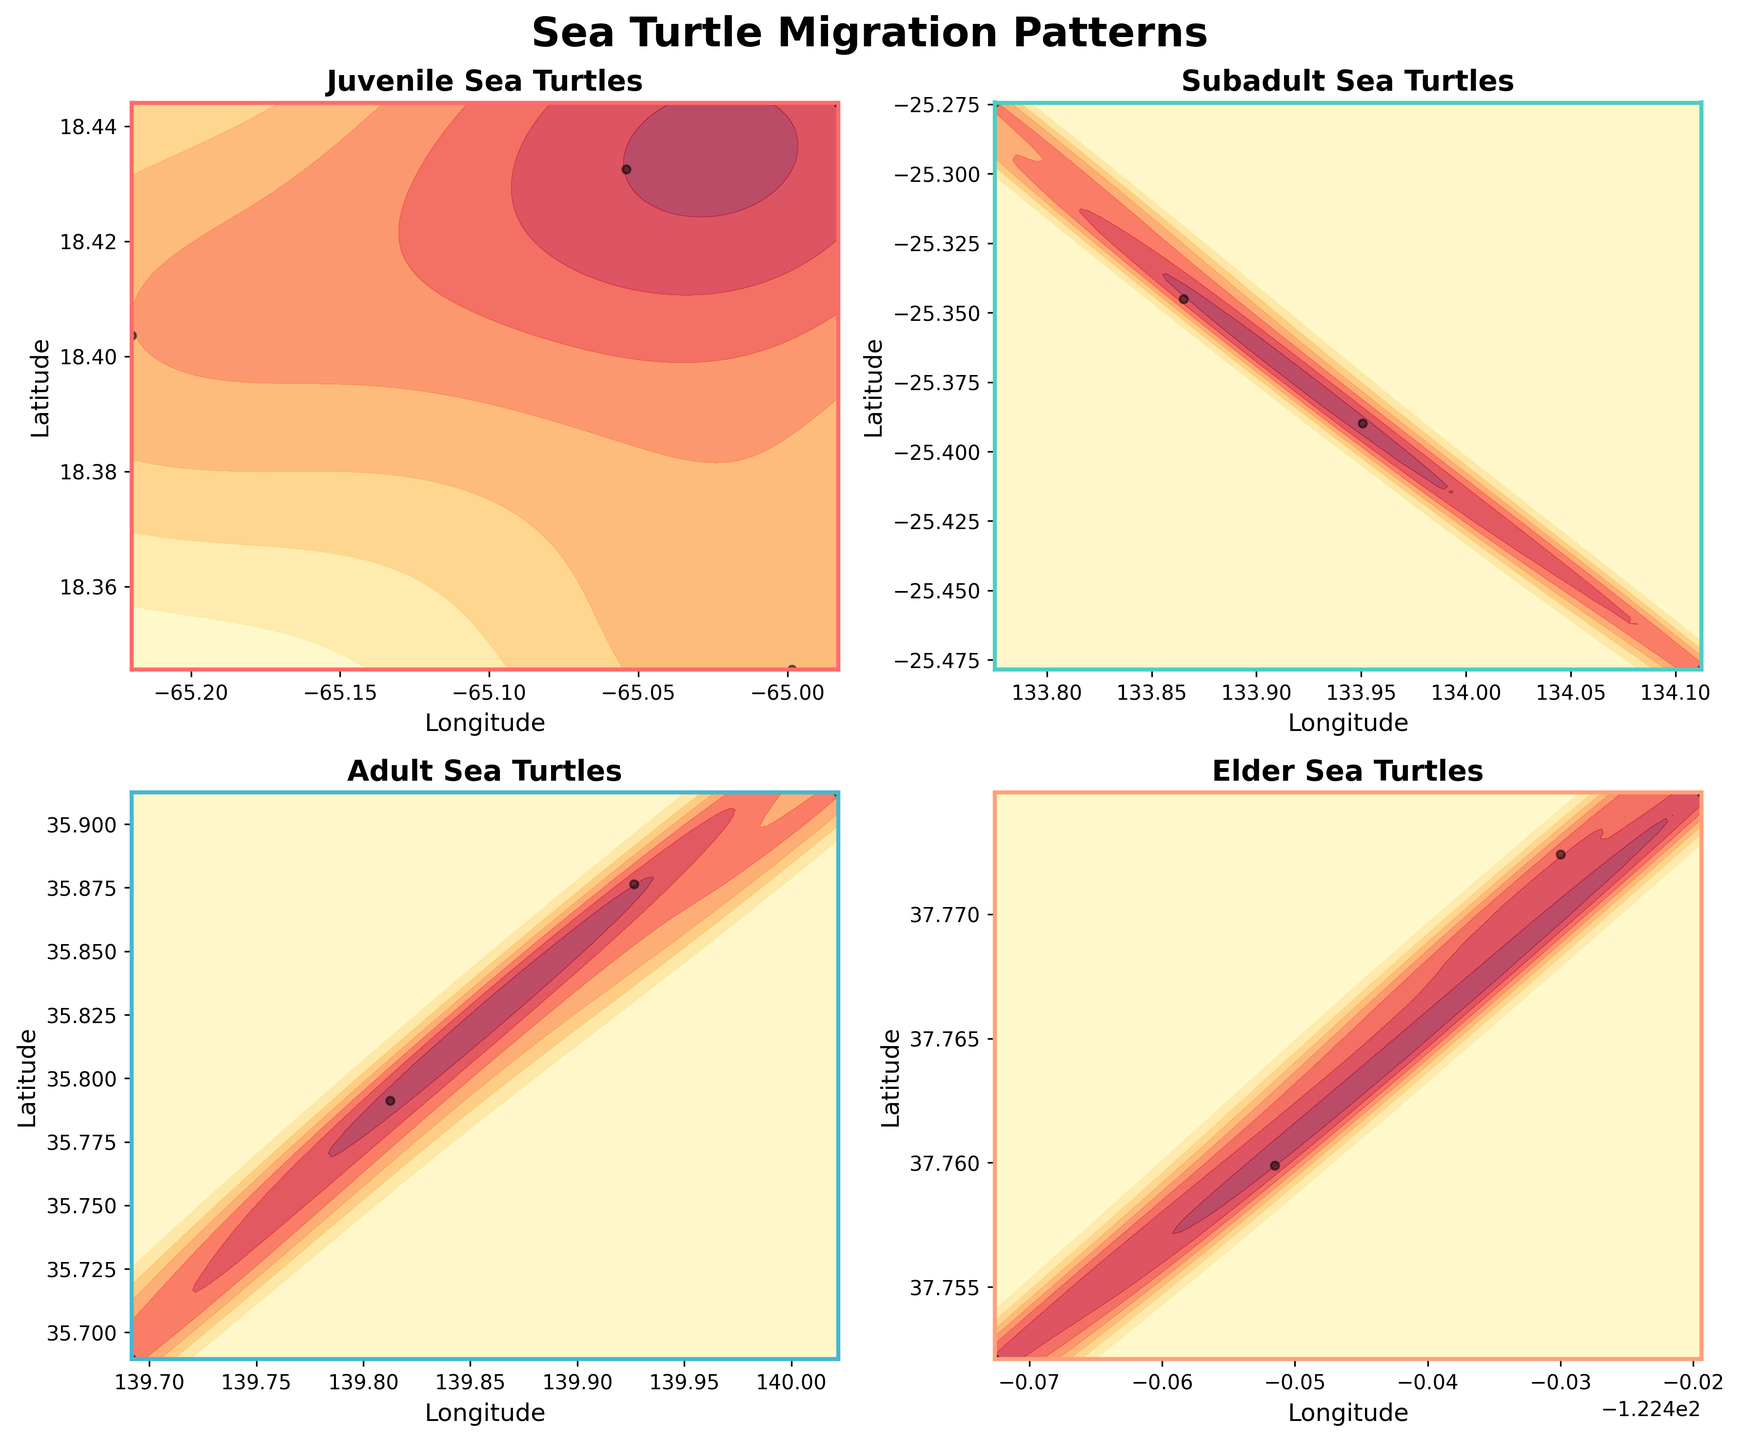Which age group is represented by the plot in the top-left subplot? The title for each subplot identifies the age group. The top-left subplot is labeled ‘Juvenile Sea Turtles’.
Answer: Juvenile What is the x-axis labeled in the bottom-right subplot? The label for the x-axis in each subplot is 'Longitude'. Therefore, the x-axis in the bottom-right subplot is labeled 'Longitude'.
Answer: Longitude Which region shows the migration pattern for subadult turtles? The subplot for subadult turtles is located in the top-right. The region is shown in the data provided as being the Indian Ocean.
Answer: Indian Ocean Which age group has the most concentrated migration pattern based on the density plot? By observing the density of the contour plots, you can see that the subadult and adult turtles have tightly packed density plots compared to the others, but the subadult group's plot appears to have the most concentrated patterns.
Answer: Subadult How do the latitude values for juvenile turtles compare to elder turtles? To compare latitudes, look at the height of the density plots on the y-axis. Juvenile turtles in the Caribbean have lower latitude values (around 18°N), whereas elder turtles in the Atlantic Ocean have higher latitude values (around 37°N).
Answer: Lower Which age group shows migration in the highest latitude? By examining each subplot, the elder turtles in the Atlantic Ocean are represented in the highest latitude region, around 37°N.
Answer: Elder Are the adult turtles' migration patterns more spread out or concentrated compared to juvenile turtles’? By examining the density plots, the adult turtles' migration patterns show a more elongated spread compared to the relatively concentrated migration pattern of juvenile turtles in the Caribbean.
Answer: More spread out In which month do the juvenile turtles begin migrating? The titles or labels might not provide this directly, but since each subplot represents various data points, the earliest month for juvenile turtles according to the data provided is June.
Answer: June 